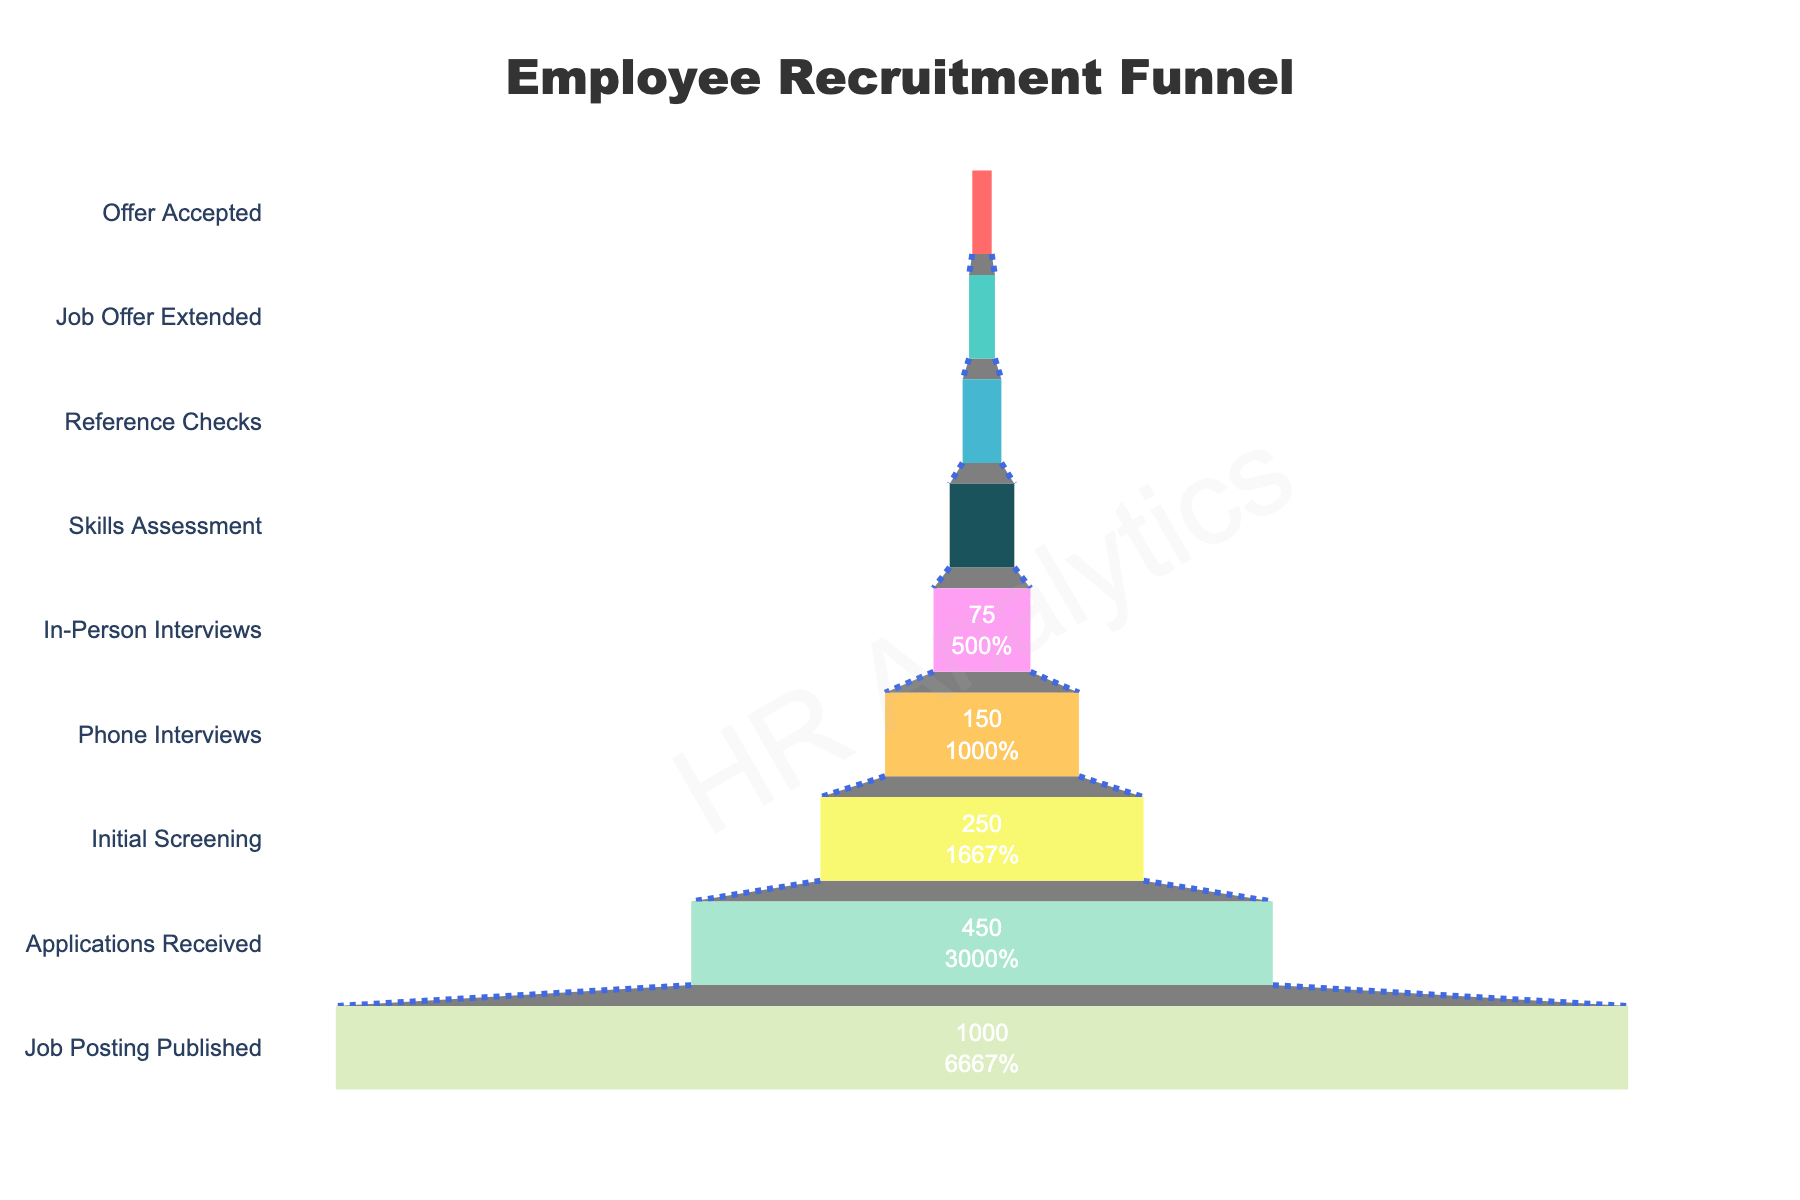what is the title of the figure? The title of the figure is typically located at the top and center of the chart. In this case, it states: "Employee Recruitment Funnel."
Answer: Employee Recruitment Funnel How many stages are there in the employee recruitment process shown in the figure? By counting each unique stage label along the y-axis of the funnel chart, you can determine the total number of stages. Here, there are 9 stages listed in the process.
Answer: 9 What is the difference in the number of applicants between the 'Job Posting Published' and the 'Applications Received' stages? The number of applicants at the 'Job Posting Published' stage is 1000, and at the 'Applications Received' stage, it is 450. The difference is 1000 - 450.
Answer: 550 Which stage shows the largest drop-off in the number of applicants? To find the largest drop-off, compare the decrease in numbers between consecutive stages. The largest drop-off is from 'Job Posting Published' (1000) to 'Applications Received' (450), which is a drop of 550 applicants.
Answer: Job Posting Published to Applications Received At which stage does the number of applicants first drop below 100? By looking at the values for each stage, you'll find that the 'In-Person Interviews' stage has 75 applicants, which is the first stage where the number drops below 100.
Answer: In-Person Interviews How does the number of applicants reduce by percentages from 'Initial Screening' to 'Phone Interviews'? The number of applicants at 'Initial Screening' is 250 and at 'Phone Interviews' is 150. The reduction is (250 - 150)/250 * 100%.
Answer: 40% What percentage of the initial 1000 applicants ultimately accept the job offer? First, note the initial number of applicants (1000). Then, the final stage, 'Offer Accepted,' has 15 applicants. The percentage is (15/1000) * 100%.
Answer: 1.5% What stage immediately precedes the 'Job Offer Extended' stage, and how many applicants are there at that stage? The stage before 'Job Offer Extended' is 'Reference Checks.' The number of applicants at the 'Reference Checks' stage is 30.
Answer: Reference Checks with 30 applicants The percentage of applicants advancing from 'Phone Interviews' to 'In-Person Interviews' is closest to what value? The number of applicants advancing from 'Phone Interviews' (150) to 'In-Person Interviews' (75) is 75. The percentage is (75/150) * 100%.
Answer: 50% 